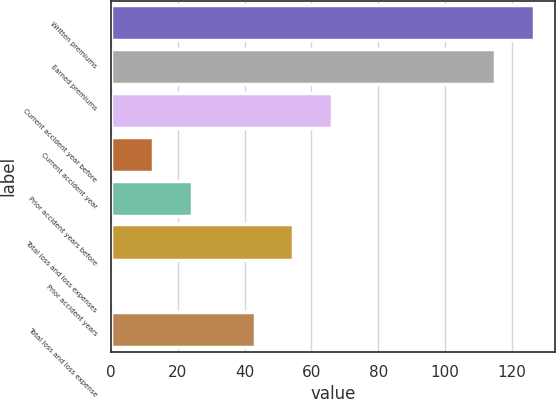Convert chart to OTSL. <chart><loc_0><loc_0><loc_500><loc_500><bar_chart><fcel>Written premiums<fcel>Earned premiums<fcel>Current accident year before<fcel>Current accident year<fcel>Prior accident years before<fcel>Total loss and loss expenses<fcel>Prior accident years<fcel>Total loss and loss expense<nl><fcel>126.61<fcel>115<fcel>66.22<fcel>12.51<fcel>24.12<fcel>54.61<fcel>0.9<fcel>43<nl></chart> 